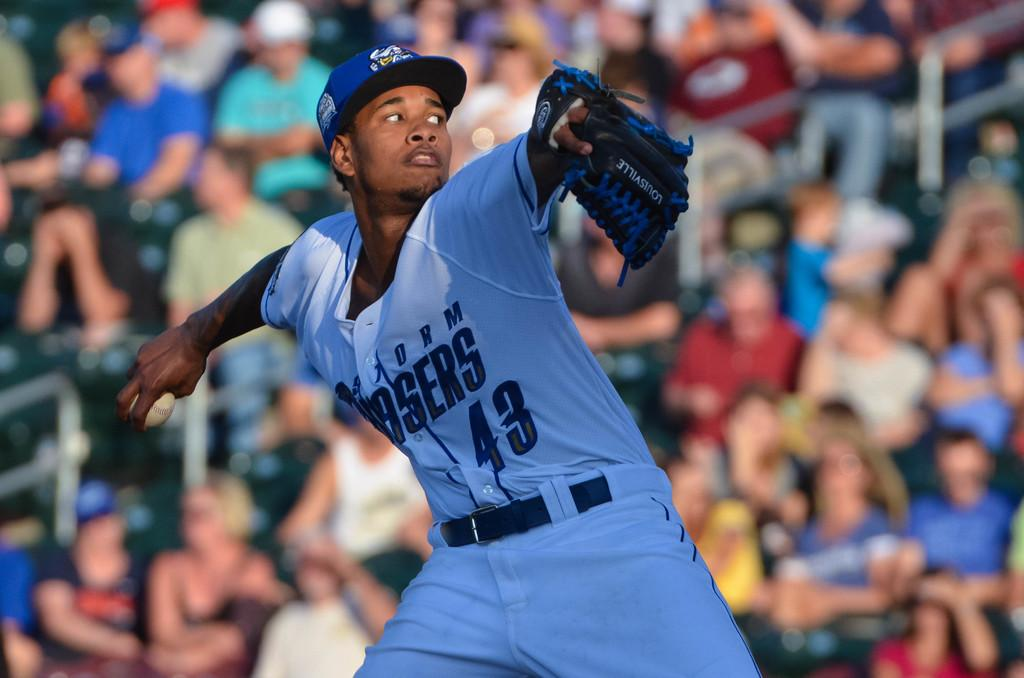<image>
Render a clear and concise summary of the photo. Baseball pitcher readies to throw the ball in a white #43 jersey with only ASERS showing 